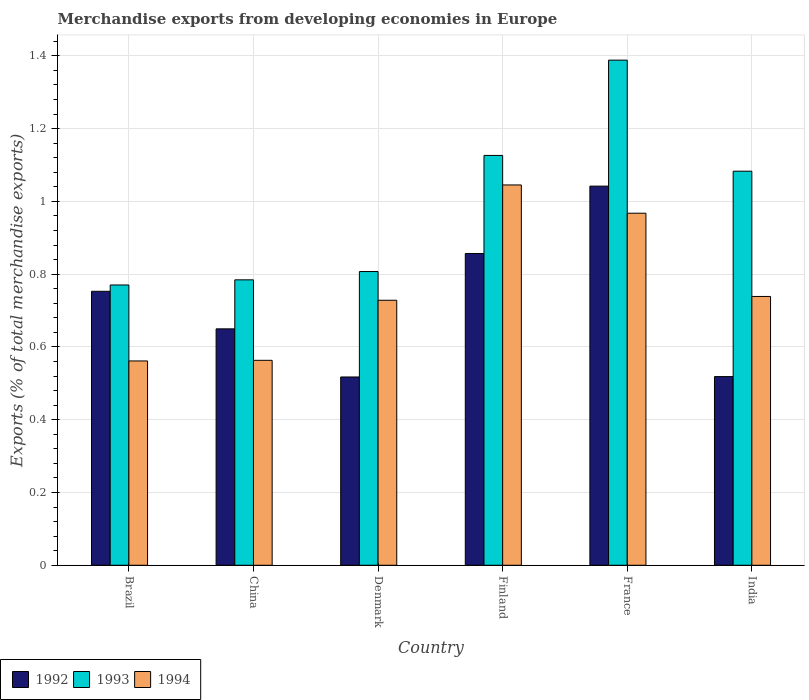How many groups of bars are there?
Offer a terse response. 6. Are the number of bars per tick equal to the number of legend labels?
Give a very brief answer. Yes. Are the number of bars on each tick of the X-axis equal?
Provide a succinct answer. Yes. How many bars are there on the 3rd tick from the left?
Ensure brevity in your answer.  3. In how many cases, is the number of bars for a given country not equal to the number of legend labels?
Your answer should be very brief. 0. What is the percentage of total merchandise exports in 1993 in China?
Give a very brief answer. 0.78. Across all countries, what is the maximum percentage of total merchandise exports in 1992?
Make the answer very short. 1.04. Across all countries, what is the minimum percentage of total merchandise exports in 1992?
Your answer should be compact. 0.52. In which country was the percentage of total merchandise exports in 1994 maximum?
Make the answer very short. Finland. In which country was the percentage of total merchandise exports in 1992 minimum?
Provide a short and direct response. Denmark. What is the total percentage of total merchandise exports in 1994 in the graph?
Provide a short and direct response. 4.6. What is the difference between the percentage of total merchandise exports in 1993 in Denmark and that in France?
Provide a short and direct response. -0.58. What is the difference between the percentage of total merchandise exports in 1993 in India and the percentage of total merchandise exports in 1994 in Finland?
Offer a terse response. 0.04. What is the average percentage of total merchandise exports in 1994 per country?
Provide a succinct answer. 0.77. What is the difference between the percentage of total merchandise exports of/in 1993 and percentage of total merchandise exports of/in 1992 in Brazil?
Your response must be concise. 0.02. In how many countries, is the percentage of total merchandise exports in 1992 greater than 0.16 %?
Ensure brevity in your answer.  6. What is the ratio of the percentage of total merchandise exports in 1993 in Finland to that in India?
Give a very brief answer. 1.04. Is the difference between the percentage of total merchandise exports in 1993 in Brazil and China greater than the difference between the percentage of total merchandise exports in 1992 in Brazil and China?
Provide a short and direct response. No. What is the difference between the highest and the second highest percentage of total merchandise exports in 1994?
Offer a very short reply. -0.08. What is the difference between the highest and the lowest percentage of total merchandise exports in 1993?
Your answer should be compact. 0.62. How many bars are there?
Give a very brief answer. 18. Are all the bars in the graph horizontal?
Keep it short and to the point. No. Are the values on the major ticks of Y-axis written in scientific E-notation?
Your answer should be compact. No. Does the graph contain grids?
Provide a succinct answer. Yes. How many legend labels are there?
Keep it short and to the point. 3. What is the title of the graph?
Make the answer very short. Merchandise exports from developing economies in Europe. What is the label or title of the Y-axis?
Provide a succinct answer. Exports (% of total merchandise exports). What is the Exports (% of total merchandise exports) in 1992 in Brazil?
Give a very brief answer. 0.75. What is the Exports (% of total merchandise exports) in 1993 in Brazil?
Make the answer very short. 0.77. What is the Exports (% of total merchandise exports) in 1994 in Brazil?
Offer a very short reply. 0.56. What is the Exports (% of total merchandise exports) in 1992 in China?
Give a very brief answer. 0.65. What is the Exports (% of total merchandise exports) of 1993 in China?
Ensure brevity in your answer.  0.78. What is the Exports (% of total merchandise exports) in 1994 in China?
Give a very brief answer. 0.56. What is the Exports (% of total merchandise exports) in 1992 in Denmark?
Ensure brevity in your answer.  0.52. What is the Exports (% of total merchandise exports) in 1993 in Denmark?
Your response must be concise. 0.81. What is the Exports (% of total merchandise exports) of 1994 in Denmark?
Provide a short and direct response. 0.73. What is the Exports (% of total merchandise exports) in 1992 in Finland?
Your answer should be very brief. 0.86. What is the Exports (% of total merchandise exports) in 1993 in Finland?
Your response must be concise. 1.13. What is the Exports (% of total merchandise exports) in 1994 in Finland?
Provide a short and direct response. 1.05. What is the Exports (% of total merchandise exports) of 1992 in France?
Offer a terse response. 1.04. What is the Exports (% of total merchandise exports) of 1993 in France?
Your response must be concise. 1.39. What is the Exports (% of total merchandise exports) in 1994 in France?
Offer a very short reply. 0.97. What is the Exports (% of total merchandise exports) in 1992 in India?
Offer a very short reply. 0.52. What is the Exports (% of total merchandise exports) in 1993 in India?
Give a very brief answer. 1.08. What is the Exports (% of total merchandise exports) in 1994 in India?
Provide a short and direct response. 0.74. Across all countries, what is the maximum Exports (% of total merchandise exports) of 1992?
Your answer should be very brief. 1.04. Across all countries, what is the maximum Exports (% of total merchandise exports) in 1993?
Give a very brief answer. 1.39. Across all countries, what is the maximum Exports (% of total merchandise exports) in 1994?
Your answer should be very brief. 1.05. Across all countries, what is the minimum Exports (% of total merchandise exports) of 1992?
Offer a very short reply. 0.52. Across all countries, what is the minimum Exports (% of total merchandise exports) of 1993?
Give a very brief answer. 0.77. Across all countries, what is the minimum Exports (% of total merchandise exports) in 1994?
Your response must be concise. 0.56. What is the total Exports (% of total merchandise exports) of 1992 in the graph?
Your answer should be very brief. 4.34. What is the total Exports (% of total merchandise exports) of 1993 in the graph?
Ensure brevity in your answer.  5.96. What is the total Exports (% of total merchandise exports) in 1994 in the graph?
Give a very brief answer. 4.6. What is the difference between the Exports (% of total merchandise exports) in 1992 in Brazil and that in China?
Your answer should be very brief. 0.1. What is the difference between the Exports (% of total merchandise exports) of 1993 in Brazil and that in China?
Make the answer very short. -0.01. What is the difference between the Exports (% of total merchandise exports) in 1994 in Brazil and that in China?
Make the answer very short. -0. What is the difference between the Exports (% of total merchandise exports) in 1992 in Brazil and that in Denmark?
Your answer should be very brief. 0.24. What is the difference between the Exports (% of total merchandise exports) in 1993 in Brazil and that in Denmark?
Your response must be concise. -0.04. What is the difference between the Exports (% of total merchandise exports) in 1994 in Brazil and that in Denmark?
Your answer should be compact. -0.17. What is the difference between the Exports (% of total merchandise exports) of 1992 in Brazil and that in Finland?
Offer a terse response. -0.1. What is the difference between the Exports (% of total merchandise exports) in 1993 in Brazil and that in Finland?
Offer a very short reply. -0.36. What is the difference between the Exports (% of total merchandise exports) of 1994 in Brazil and that in Finland?
Ensure brevity in your answer.  -0.48. What is the difference between the Exports (% of total merchandise exports) in 1992 in Brazil and that in France?
Provide a succinct answer. -0.29. What is the difference between the Exports (% of total merchandise exports) of 1993 in Brazil and that in France?
Offer a terse response. -0.62. What is the difference between the Exports (% of total merchandise exports) of 1994 in Brazil and that in France?
Provide a short and direct response. -0.41. What is the difference between the Exports (% of total merchandise exports) in 1992 in Brazil and that in India?
Your answer should be compact. 0.23. What is the difference between the Exports (% of total merchandise exports) of 1993 in Brazil and that in India?
Ensure brevity in your answer.  -0.31. What is the difference between the Exports (% of total merchandise exports) in 1994 in Brazil and that in India?
Keep it short and to the point. -0.18. What is the difference between the Exports (% of total merchandise exports) in 1992 in China and that in Denmark?
Provide a succinct answer. 0.13. What is the difference between the Exports (% of total merchandise exports) of 1993 in China and that in Denmark?
Your response must be concise. -0.02. What is the difference between the Exports (% of total merchandise exports) in 1994 in China and that in Denmark?
Ensure brevity in your answer.  -0.17. What is the difference between the Exports (% of total merchandise exports) of 1992 in China and that in Finland?
Offer a very short reply. -0.21. What is the difference between the Exports (% of total merchandise exports) of 1993 in China and that in Finland?
Offer a terse response. -0.34. What is the difference between the Exports (% of total merchandise exports) in 1994 in China and that in Finland?
Offer a terse response. -0.48. What is the difference between the Exports (% of total merchandise exports) of 1992 in China and that in France?
Provide a succinct answer. -0.39. What is the difference between the Exports (% of total merchandise exports) in 1993 in China and that in France?
Your answer should be compact. -0.6. What is the difference between the Exports (% of total merchandise exports) in 1994 in China and that in France?
Provide a succinct answer. -0.4. What is the difference between the Exports (% of total merchandise exports) in 1992 in China and that in India?
Make the answer very short. 0.13. What is the difference between the Exports (% of total merchandise exports) of 1993 in China and that in India?
Your answer should be compact. -0.3. What is the difference between the Exports (% of total merchandise exports) in 1994 in China and that in India?
Offer a terse response. -0.18. What is the difference between the Exports (% of total merchandise exports) in 1992 in Denmark and that in Finland?
Your answer should be very brief. -0.34. What is the difference between the Exports (% of total merchandise exports) of 1993 in Denmark and that in Finland?
Give a very brief answer. -0.32. What is the difference between the Exports (% of total merchandise exports) in 1994 in Denmark and that in Finland?
Your response must be concise. -0.32. What is the difference between the Exports (% of total merchandise exports) in 1992 in Denmark and that in France?
Make the answer very short. -0.52. What is the difference between the Exports (% of total merchandise exports) in 1993 in Denmark and that in France?
Your response must be concise. -0.58. What is the difference between the Exports (% of total merchandise exports) of 1994 in Denmark and that in France?
Give a very brief answer. -0.24. What is the difference between the Exports (% of total merchandise exports) in 1992 in Denmark and that in India?
Offer a very short reply. -0. What is the difference between the Exports (% of total merchandise exports) in 1993 in Denmark and that in India?
Provide a succinct answer. -0.28. What is the difference between the Exports (% of total merchandise exports) in 1994 in Denmark and that in India?
Your answer should be compact. -0.01. What is the difference between the Exports (% of total merchandise exports) in 1992 in Finland and that in France?
Your response must be concise. -0.19. What is the difference between the Exports (% of total merchandise exports) of 1993 in Finland and that in France?
Your answer should be very brief. -0.26. What is the difference between the Exports (% of total merchandise exports) in 1994 in Finland and that in France?
Keep it short and to the point. 0.08. What is the difference between the Exports (% of total merchandise exports) in 1992 in Finland and that in India?
Provide a short and direct response. 0.34. What is the difference between the Exports (% of total merchandise exports) in 1993 in Finland and that in India?
Your answer should be very brief. 0.04. What is the difference between the Exports (% of total merchandise exports) in 1994 in Finland and that in India?
Your response must be concise. 0.31. What is the difference between the Exports (% of total merchandise exports) of 1992 in France and that in India?
Keep it short and to the point. 0.52. What is the difference between the Exports (% of total merchandise exports) of 1993 in France and that in India?
Make the answer very short. 0.31. What is the difference between the Exports (% of total merchandise exports) of 1994 in France and that in India?
Offer a terse response. 0.23. What is the difference between the Exports (% of total merchandise exports) in 1992 in Brazil and the Exports (% of total merchandise exports) in 1993 in China?
Provide a succinct answer. -0.03. What is the difference between the Exports (% of total merchandise exports) in 1992 in Brazil and the Exports (% of total merchandise exports) in 1994 in China?
Provide a succinct answer. 0.19. What is the difference between the Exports (% of total merchandise exports) of 1993 in Brazil and the Exports (% of total merchandise exports) of 1994 in China?
Make the answer very short. 0.21. What is the difference between the Exports (% of total merchandise exports) of 1992 in Brazil and the Exports (% of total merchandise exports) of 1993 in Denmark?
Provide a succinct answer. -0.05. What is the difference between the Exports (% of total merchandise exports) in 1992 in Brazil and the Exports (% of total merchandise exports) in 1994 in Denmark?
Your answer should be compact. 0.02. What is the difference between the Exports (% of total merchandise exports) in 1993 in Brazil and the Exports (% of total merchandise exports) in 1994 in Denmark?
Keep it short and to the point. 0.04. What is the difference between the Exports (% of total merchandise exports) of 1992 in Brazil and the Exports (% of total merchandise exports) of 1993 in Finland?
Your response must be concise. -0.37. What is the difference between the Exports (% of total merchandise exports) of 1992 in Brazil and the Exports (% of total merchandise exports) of 1994 in Finland?
Provide a short and direct response. -0.29. What is the difference between the Exports (% of total merchandise exports) in 1993 in Brazil and the Exports (% of total merchandise exports) in 1994 in Finland?
Your answer should be very brief. -0.27. What is the difference between the Exports (% of total merchandise exports) of 1992 in Brazil and the Exports (% of total merchandise exports) of 1993 in France?
Your answer should be compact. -0.64. What is the difference between the Exports (% of total merchandise exports) of 1992 in Brazil and the Exports (% of total merchandise exports) of 1994 in France?
Your answer should be compact. -0.21. What is the difference between the Exports (% of total merchandise exports) in 1993 in Brazil and the Exports (% of total merchandise exports) in 1994 in France?
Offer a terse response. -0.2. What is the difference between the Exports (% of total merchandise exports) in 1992 in Brazil and the Exports (% of total merchandise exports) in 1993 in India?
Provide a succinct answer. -0.33. What is the difference between the Exports (% of total merchandise exports) of 1992 in Brazil and the Exports (% of total merchandise exports) of 1994 in India?
Ensure brevity in your answer.  0.01. What is the difference between the Exports (% of total merchandise exports) in 1993 in Brazil and the Exports (% of total merchandise exports) in 1994 in India?
Ensure brevity in your answer.  0.03. What is the difference between the Exports (% of total merchandise exports) in 1992 in China and the Exports (% of total merchandise exports) in 1993 in Denmark?
Your answer should be compact. -0.16. What is the difference between the Exports (% of total merchandise exports) in 1992 in China and the Exports (% of total merchandise exports) in 1994 in Denmark?
Your answer should be compact. -0.08. What is the difference between the Exports (% of total merchandise exports) of 1993 in China and the Exports (% of total merchandise exports) of 1994 in Denmark?
Offer a very short reply. 0.06. What is the difference between the Exports (% of total merchandise exports) of 1992 in China and the Exports (% of total merchandise exports) of 1993 in Finland?
Provide a succinct answer. -0.48. What is the difference between the Exports (% of total merchandise exports) in 1992 in China and the Exports (% of total merchandise exports) in 1994 in Finland?
Give a very brief answer. -0.4. What is the difference between the Exports (% of total merchandise exports) of 1993 in China and the Exports (% of total merchandise exports) of 1994 in Finland?
Make the answer very short. -0.26. What is the difference between the Exports (% of total merchandise exports) of 1992 in China and the Exports (% of total merchandise exports) of 1993 in France?
Offer a very short reply. -0.74. What is the difference between the Exports (% of total merchandise exports) of 1992 in China and the Exports (% of total merchandise exports) of 1994 in France?
Keep it short and to the point. -0.32. What is the difference between the Exports (% of total merchandise exports) of 1993 in China and the Exports (% of total merchandise exports) of 1994 in France?
Your response must be concise. -0.18. What is the difference between the Exports (% of total merchandise exports) of 1992 in China and the Exports (% of total merchandise exports) of 1993 in India?
Keep it short and to the point. -0.43. What is the difference between the Exports (% of total merchandise exports) of 1992 in China and the Exports (% of total merchandise exports) of 1994 in India?
Offer a very short reply. -0.09. What is the difference between the Exports (% of total merchandise exports) in 1993 in China and the Exports (% of total merchandise exports) in 1994 in India?
Keep it short and to the point. 0.05. What is the difference between the Exports (% of total merchandise exports) in 1992 in Denmark and the Exports (% of total merchandise exports) in 1993 in Finland?
Ensure brevity in your answer.  -0.61. What is the difference between the Exports (% of total merchandise exports) of 1992 in Denmark and the Exports (% of total merchandise exports) of 1994 in Finland?
Ensure brevity in your answer.  -0.53. What is the difference between the Exports (% of total merchandise exports) in 1993 in Denmark and the Exports (% of total merchandise exports) in 1994 in Finland?
Ensure brevity in your answer.  -0.24. What is the difference between the Exports (% of total merchandise exports) in 1992 in Denmark and the Exports (% of total merchandise exports) in 1993 in France?
Provide a short and direct response. -0.87. What is the difference between the Exports (% of total merchandise exports) in 1992 in Denmark and the Exports (% of total merchandise exports) in 1994 in France?
Your response must be concise. -0.45. What is the difference between the Exports (% of total merchandise exports) of 1993 in Denmark and the Exports (% of total merchandise exports) of 1994 in France?
Your answer should be compact. -0.16. What is the difference between the Exports (% of total merchandise exports) of 1992 in Denmark and the Exports (% of total merchandise exports) of 1993 in India?
Your answer should be very brief. -0.57. What is the difference between the Exports (% of total merchandise exports) in 1992 in Denmark and the Exports (% of total merchandise exports) in 1994 in India?
Keep it short and to the point. -0.22. What is the difference between the Exports (% of total merchandise exports) of 1993 in Denmark and the Exports (% of total merchandise exports) of 1994 in India?
Ensure brevity in your answer.  0.07. What is the difference between the Exports (% of total merchandise exports) in 1992 in Finland and the Exports (% of total merchandise exports) in 1993 in France?
Your answer should be very brief. -0.53. What is the difference between the Exports (% of total merchandise exports) of 1992 in Finland and the Exports (% of total merchandise exports) of 1994 in France?
Make the answer very short. -0.11. What is the difference between the Exports (% of total merchandise exports) of 1993 in Finland and the Exports (% of total merchandise exports) of 1994 in France?
Keep it short and to the point. 0.16. What is the difference between the Exports (% of total merchandise exports) of 1992 in Finland and the Exports (% of total merchandise exports) of 1993 in India?
Keep it short and to the point. -0.23. What is the difference between the Exports (% of total merchandise exports) in 1992 in Finland and the Exports (% of total merchandise exports) in 1994 in India?
Offer a very short reply. 0.12. What is the difference between the Exports (% of total merchandise exports) of 1993 in Finland and the Exports (% of total merchandise exports) of 1994 in India?
Offer a terse response. 0.39. What is the difference between the Exports (% of total merchandise exports) in 1992 in France and the Exports (% of total merchandise exports) in 1993 in India?
Offer a very short reply. -0.04. What is the difference between the Exports (% of total merchandise exports) of 1992 in France and the Exports (% of total merchandise exports) of 1994 in India?
Give a very brief answer. 0.3. What is the difference between the Exports (% of total merchandise exports) in 1993 in France and the Exports (% of total merchandise exports) in 1994 in India?
Ensure brevity in your answer.  0.65. What is the average Exports (% of total merchandise exports) of 1992 per country?
Offer a very short reply. 0.72. What is the average Exports (% of total merchandise exports) of 1993 per country?
Your answer should be compact. 0.99. What is the average Exports (% of total merchandise exports) in 1994 per country?
Your answer should be compact. 0.77. What is the difference between the Exports (% of total merchandise exports) in 1992 and Exports (% of total merchandise exports) in 1993 in Brazil?
Make the answer very short. -0.02. What is the difference between the Exports (% of total merchandise exports) of 1992 and Exports (% of total merchandise exports) of 1994 in Brazil?
Make the answer very short. 0.19. What is the difference between the Exports (% of total merchandise exports) in 1993 and Exports (% of total merchandise exports) in 1994 in Brazil?
Offer a very short reply. 0.21. What is the difference between the Exports (% of total merchandise exports) in 1992 and Exports (% of total merchandise exports) in 1993 in China?
Your response must be concise. -0.13. What is the difference between the Exports (% of total merchandise exports) in 1992 and Exports (% of total merchandise exports) in 1994 in China?
Your answer should be very brief. 0.09. What is the difference between the Exports (% of total merchandise exports) of 1993 and Exports (% of total merchandise exports) of 1994 in China?
Provide a succinct answer. 0.22. What is the difference between the Exports (% of total merchandise exports) of 1992 and Exports (% of total merchandise exports) of 1993 in Denmark?
Your response must be concise. -0.29. What is the difference between the Exports (% of total merchandise exports) in 1992 and Exports (% of total merchandise exports) in 1994 in Denmark?
Your answer should be very brief. -0.21. What is the difference between the Exports (% of total merchandise exports) in 1993 and Exports (% of total merchandise exports) in 1994 in Denmark?
Provide a succinct answer. 0.08. What is the difference between the Exports (% of total merchandise exports) in 1992 and Exports (% of total merchandise exports) in 1993 in Finland?
Offer a very short reply. -0.27. What is the difference between the Exports (% of total merchandise exports) in 1992 and Exports (% of total merchandise exports) in 1994 in Finland?
Offer a terse response. -0.19. What is the difference between the Exports (% of total merchandise exports) in 1993 and Exports (% of total merchandise exports) in 1994 in Finland?
Ensure brevity in your answer.  0.08. What is the difference between the Exports (% of total merchandise exports) of 1992 and Exports (% of total merchandise exports) of 1993 in France?
Your answer should be very brief. -0.35. What is the difference between the Exports (% of total merchandise exports) of 1992 and Exports (% of total merchandise exports) of 1994 in France?
Offer a very short reply. 0.07. What is the difference between the Exports (% of total merchandise exports) of 1993 and Exports (% of total merchandise exports) of 1994 in France?
Provide a short and direct response. 0.42. What is the difference between the Exports (% of total merchandise exports) of 1992 and Exports (% of total merchandise exports) of 1993 in India?
Provide a succinct answer. -0.56. What is the difference between the Exports (% of total merchandise exports) in 1992 and Exports (% of total merchandise exports) in 1994 in India?
Make the answer very short. -0.22. What is the difference between the Exports (% of total merchandise exports) of 1993 and Exports (% of total merchandise exports) of 1994 in India?
Keep it short and to the point. 0.34. What is the ratio of the Exports (% of total merchandise exports) in 1992 in Brazil to that in China?
Offer a very short reply. 1.16. What is the ratio of the Exports (% of total merchandise exports) of 1993 in Brazil to that in China?
Provide a succinct answer. 0.98. What is the ratio of the Exports (% of total merchandise exports) of 1992 in Brazil to that in Denmark?
Offer a terse response. 1.46. What is the ratio of the Exports (% of total merchandise exports) in 1993 in Brazil to that in Denmark?
Ensure brevity in your answer.  0.95. What is the ratio of the Exports (% of total merchandise exports) in 1994 in Brazil to that in Denmark?
Your answer should be very brief. 0.77. What is the ratio of the Exports (% of total merchandise exports) of 1992 in Brazil to that in Finland?
Keep it short and to the point. 0.88. What is the ratio of the Exports (% of total merchandise exports) in 1993 in Brazil to that in Finland?
Provide a succinct answer. 0.68. What is the ratio of the Exports (% of total merchandise exports) in 1994 in Brazil to that in Finland?
Your response must be concise. 0.54. What is the ratio of the Exports (% of total merchandise exports) in 1992 in Brazil to that in France?
Make the answer very short. 0.72. What is the ratio of the Exports (% of total merchandise exports) of 1993 in Brazil to that in France?
Offer a terse response. 0.55. What is the ratio of the Exports (% of total merchandise exports) in 1994 in Brazil to that in France?
Give a very brief answer. 0.58. What is the ratio of the Exports (% of total merchandise exports) in 1992 in Brazil to that in India?
Your answer should be compact. 1.45. What is the ratio of the Exports (% of total merchandise exports) of 1993 in Brazil to that in India?
Provide a short and direct response. 0.71. What is the ratio of the Exports (% of total merchandise exports) in 1994 in Brazil to that in India?
Make the answer very short. 0.76. What is the ratio of the Exports (% of total merchandise exports) of 1992 in China to that in Denmark?
Offer a very short reply. 1.26. What is the ratio of the Exports (% of total merchandise exports) in 1993 in China to that in Denmark?
Keep it short and to the point. 0.97. What is the ratio of the Exports (% of total merchandise exports) of 1994 in China to that in Denmark?
Make the answer very short. 0.77. What is the ratio of the Exports (% of total merchandise exports) of 1992 in China to that in Finland?
Offer a terse response. 0.76. What is the ratio of the Exports (% of total merchandise exports) in 1993 in China to that in Finland?
Make the answer very short. 0.7. What is the ratio of the Exports (% of total merchandise exports) of 1994 in China to that in Finland?
Offer a very short reply. 0.54. What is the ratio of the Exports (% of total merchandise exports) in 1992 in China to that in France?
Give a very brief answer. 0.62. What is the ratio of the Exports (% of total merchandise exports) of 1993 in China to that in France?
Your answer should be compact. 0.57. What is the ratio of the Exports (% of total merchandise exports) in 1994 in China to that in France?
Offer a very short reply. 0.58. What is the ratio of the Exports (% of total merchandise exports) in 1992 in China to that in India?
Provide a succinct answer. 1.25. What is the ratio of the Exports (% of total merchandise exports) in 1993 in China to that in India?
Offer a terse response. 0.72. What is the ratio of the Exports (% of total merchandise exports) in 1994 in China to that in India?
Provide a succinct answer. 0.76. What is the ratio of the Exports (% of total merchandise exports) in 1992 in Denmark to that in Finland?
Your answer should be very brief. 0.6. What is the ratio of the Exports (% of total merchandise exports) of 1993 in Denmark to that in Finland?
Give a very brief answer. 0.72. What is the ratio of the Exports (% of total merchandise exports) of 1994 in Denmark to that in Finland?
Your answer should be compact. 0.7. What is the ratio of the Exports (% of total merchandise exports) in 1992 in Denmark to that in France?
Offer a very short reply. 0.5. What is the ratio of the Exports (% of total merchandise exports) in 1993 in Denmark to that in France?
Ensure brevity in your answer.  0.58. What is the ratio of the Exports (% of total merchandise exports) of 1994 in Denmark to that in France?
Provide a succinct answer. 0.75. What is the ratio of the Exports (% of total merchandise exports) of 1992 in Denmark to that in India?
Ensure brevity in your answer.  1. What is the ratio of the Exports (% of total merchandise exports) in 1993 in Denmark to that in India?
Make the answer very short. 0.75. What is the ratio of the Exports (% of total merchandise exports) of 1994 in Denmark to that in India?
Make the answer very short. 0.99. What is the ratio of the Exports (% of total merchandise exports) of 1992 in Finland to that in France?
Provide a short and direct response. 0.82. What is the ratio of the Exports (% of total merchandise exports) of 1993 in Finland to that in France?
Keep it short and to the point. 0.81. What is the ratio of the Exports (% of total merchandise exports) in 1994 in Finland to that in France?
Keep it short and to the point. 1.08. What is the ratio of the Exports (% of total merchandise exports) in 1992 in Finland to that in India?
Keep it short and to the point. 1.65. What is the ratio of the Exports (% of total merchandise exports) of 1993 in Finland to that in India?
Keep it short and to the point. 1.04. What is the ratio of the Exports (% of total merchandise exports) of 1994 in Finland to that in India?
Your response must be concise. 1.41. What is the ratio of the Exports (% of total merchandise exports) of 1992 in France to that in India?
Provide a succinct answer. 2.01. What is the ratio of the Exports (% of total merchandise exports) in 1993 in France to that in India?
Make the answer very short. 1.28. What is the ratio of the Exports (% of total merchandise exports) in 1994 in France to that in India?
Your response must be concise. 1.31. What is the difference between the highest and the second highest Exports (% of total merchandise exports) of 1992?
Give a very brief answer. 0.19. What is the difference between the highest and the second highest Exports (% of total merchandise exports) in 1993?
Give a very brief answer. 0.26. What is the difference between the highest and the second highest Exports (% of total merchandise exports) in 1994?
Your response must be concise. 0.08. What is the difference between the highest and the lowest Exports (% of total merchandise exports) of 1992?
Offer a terse response. 0.52. What is the difference between the highest and the lowest Exports (% of total merchandise exports) of 1993?
Provide a short and direct response. 0.62. What is the difference between the highest and the lowest Exports (% of total merchandise exports) in 1994?
Provide a short and direct response. 0.48. 